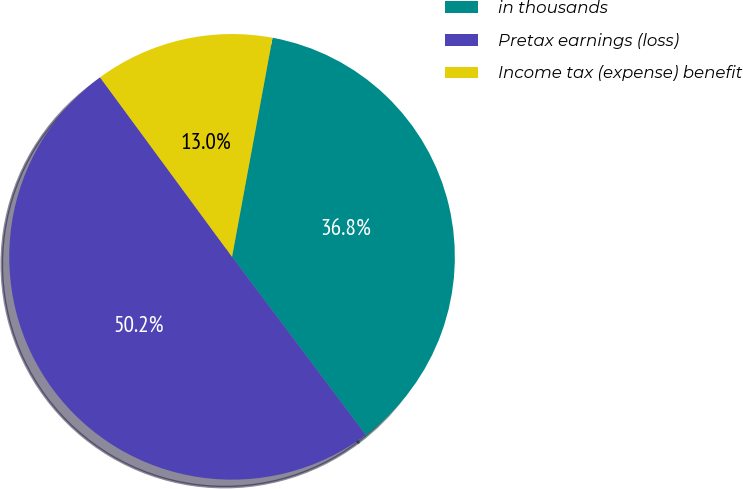Convert chart. <chart><loc_0><loc_0><loc_500><loc_500><pie_chart><fcel>in thousands<fcel>Pretax earnings (loss)<fcel>Income tax (expense) benefit<nl><fcel>36.84%<fcel>50.16%<fcel>13.0%<nl></chart> 